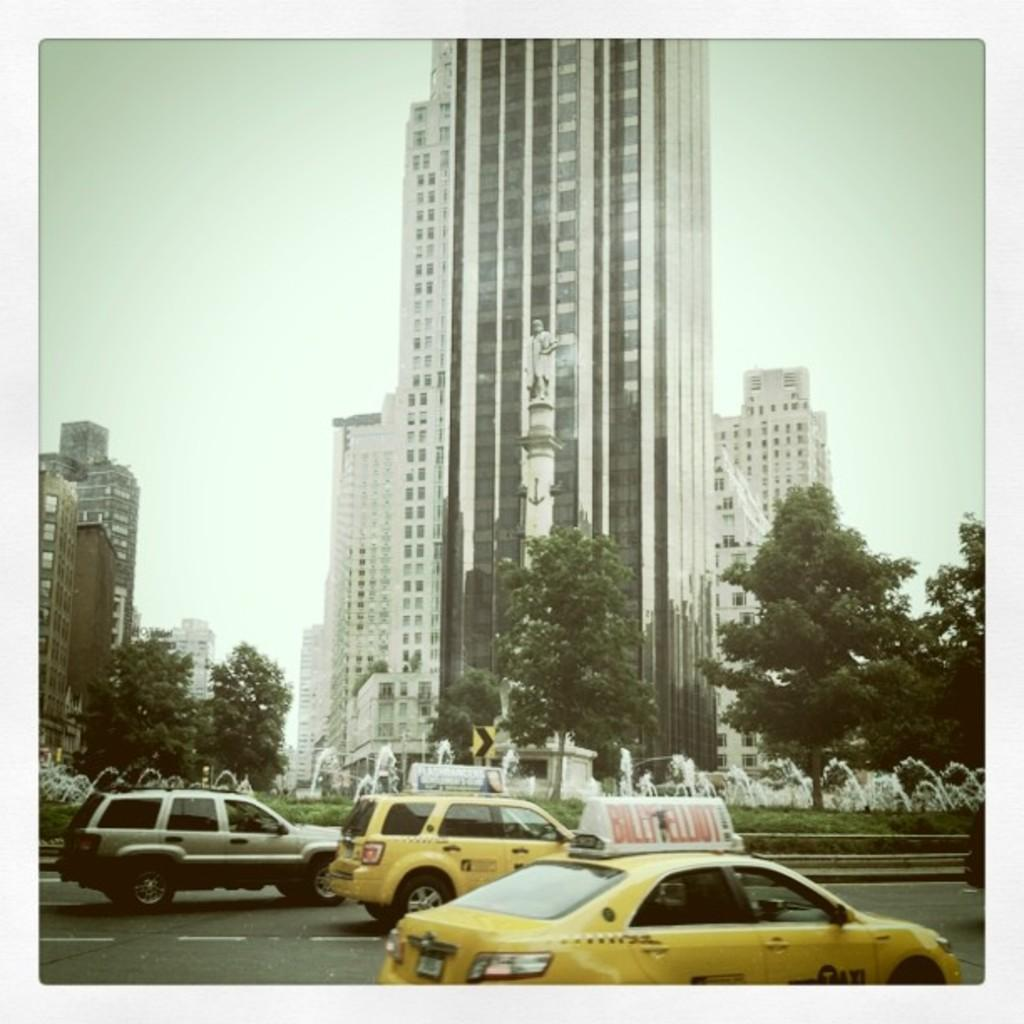<image>
Share a concise interpretation of the image provided. The taxis passed near the old building of the former regime. 